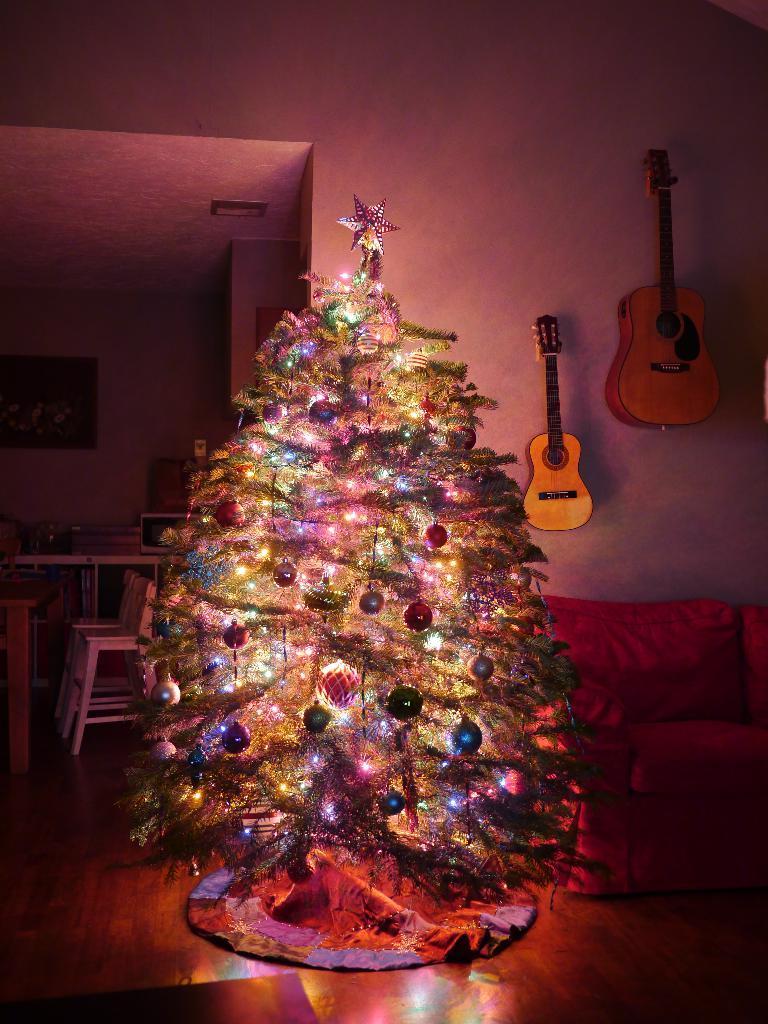How would you summarize this image in a sentence or two? In this image i can see a Christmas tree and a couch. In the background i can see a wall and few guitars. 